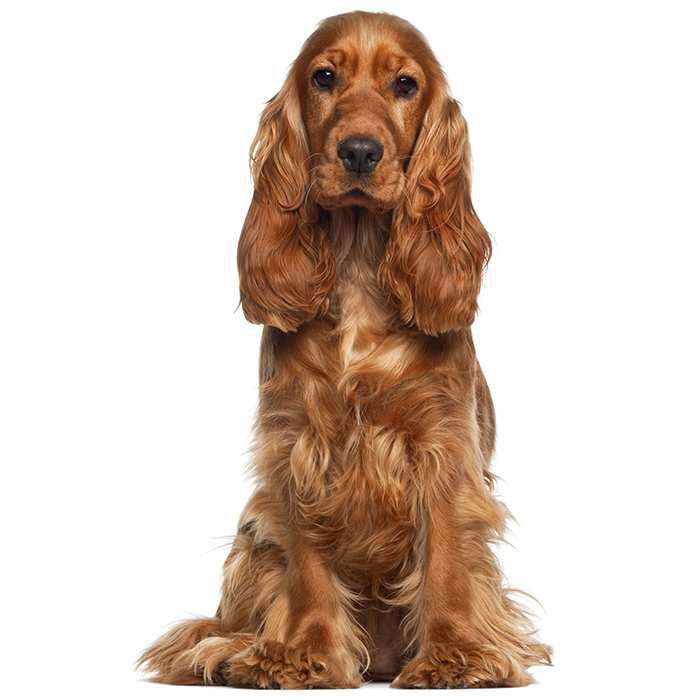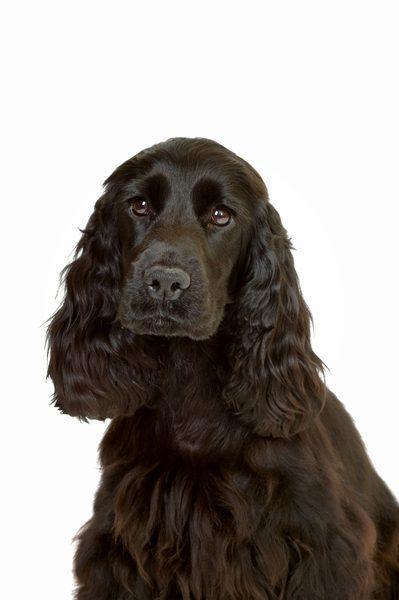The first image is the image on the left, the second image is the image on the right. Evaluate the accuracy of this statement regarding the images: "The image on the right contains a dark colored dog.". Is it true? Answer yes or no. Yes. 